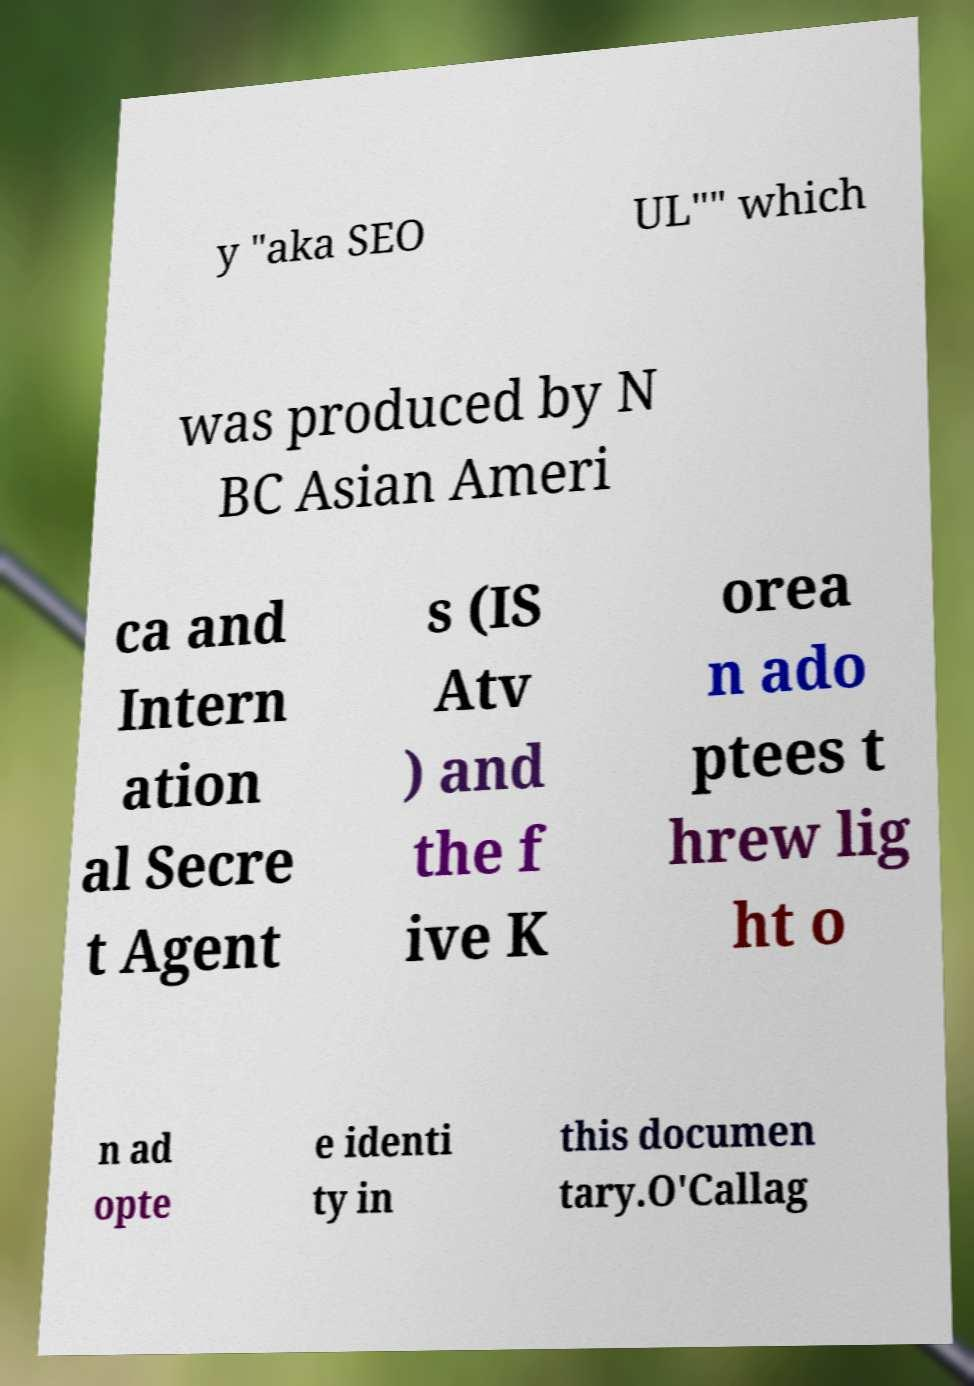I need the written content from this picture converted into text. Can you do that? y "aka SEO UL"" which was produced by N BC Asian Ameri ca and Intern ation al Secre t Agent s (IS Atv ) and the f ive K orea n ado ptees t hrew lig ht o n ad opte e identi ty in this documen tary.O'Callag 